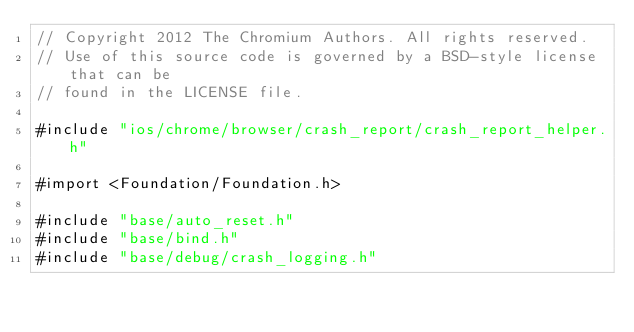<code> <loc_0><loc_0><loc_500><loc_500><_ObjectiveC_>// Copyright 2012 The Chromium Authors. All rights reserved.
// Use of this source code is governed by a BSD-style license that can be
// found in the LICENSE file.

#include "ios/chrome/browser/crash_report/crash_report_helper.h"

#import <Foundation/Foundation.h>

#include "base/auto_reset.h"
#include "base/bind.h"
#include "base/debug/crash_logging.h"</code> 